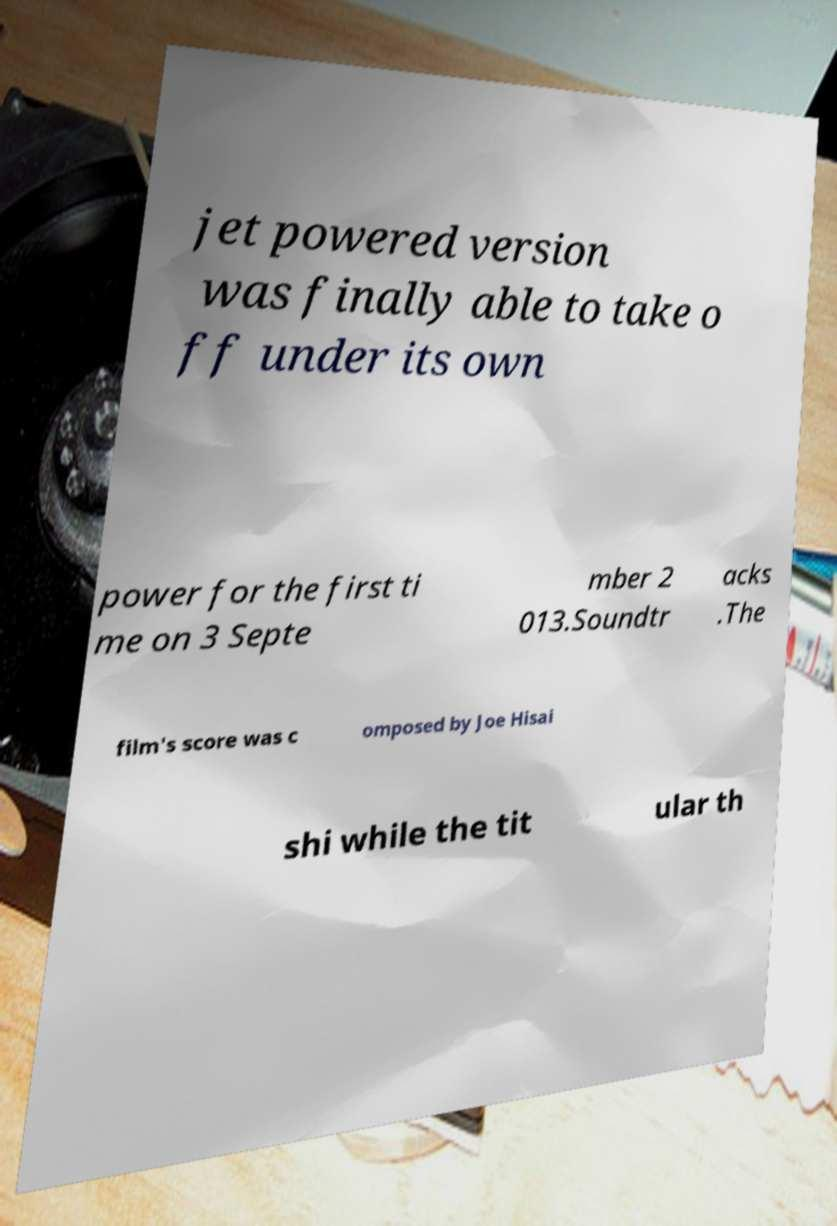For documentation purposes, I need the text within this image transcribed. Could you provide that? jet powered version was finally able to take o ff under its own power for the first ti me on 3 Septe mber 2 013.Soundtr acks .The film's score was c omposed by Joe Hisai shi while the tit ular th 